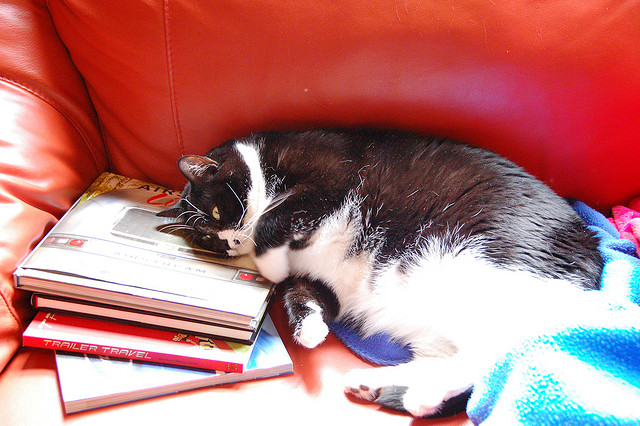Please identify all text content in this image. TRAILER TRAVEL AIR Li 